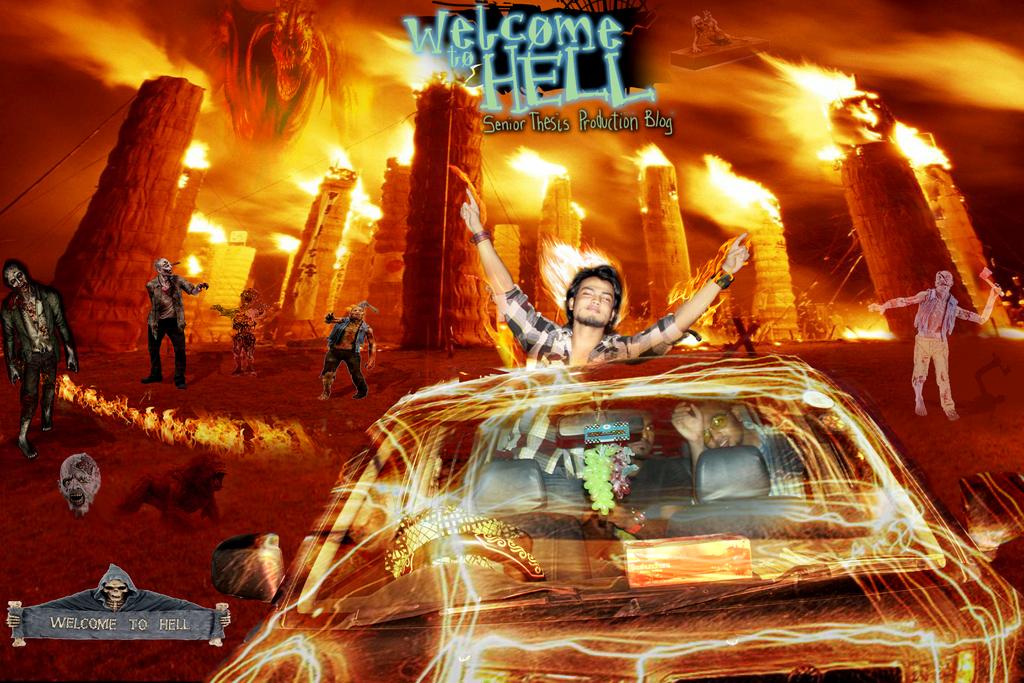Which one would you choose heaven or hell/?
Offer a very short reply. Hell. 